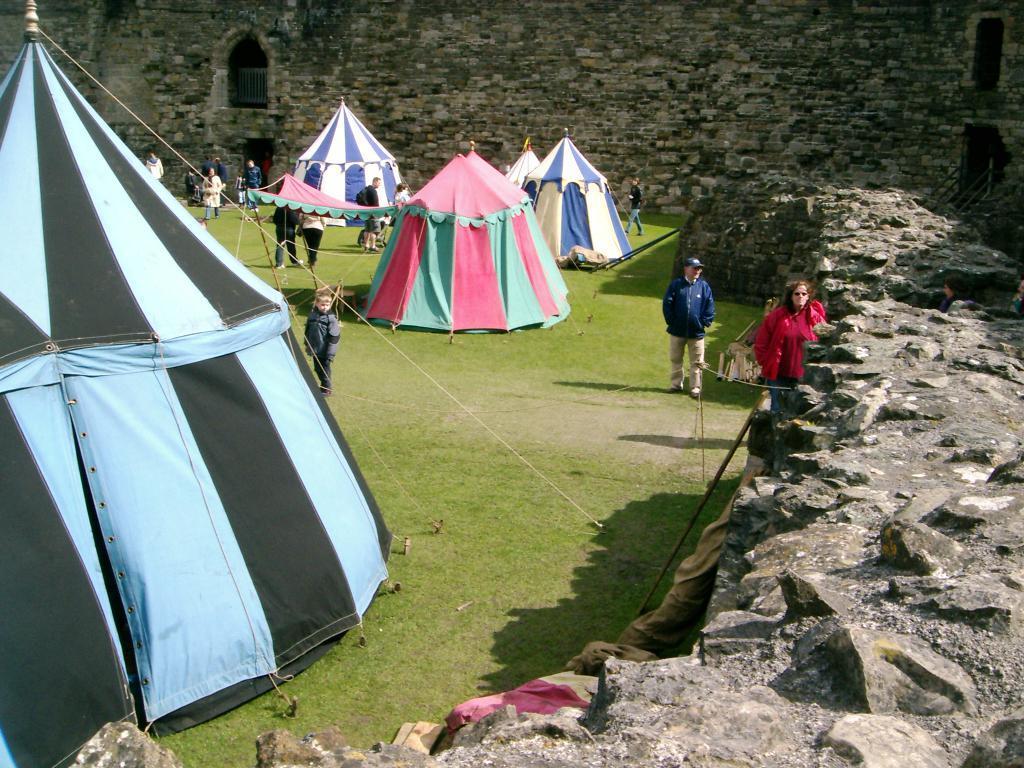In one or two sentences, can you explain what this image depicts? In this image we can see tents. Also there are many people. On the ground there is grass. On the right side there is a wall with rocks. In the back there is a wall with windows. 